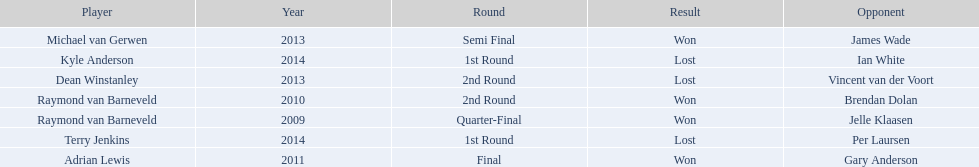What are all the years? 2009, 2010, 2011, 2013, 2013, 2014, 2014. Of these, which ones are 2014? 2014, 2014. Of these dates which one is associated with a player other than kyle anderson? 2014. What is the player name associated with this year? Terry Jenkins. 